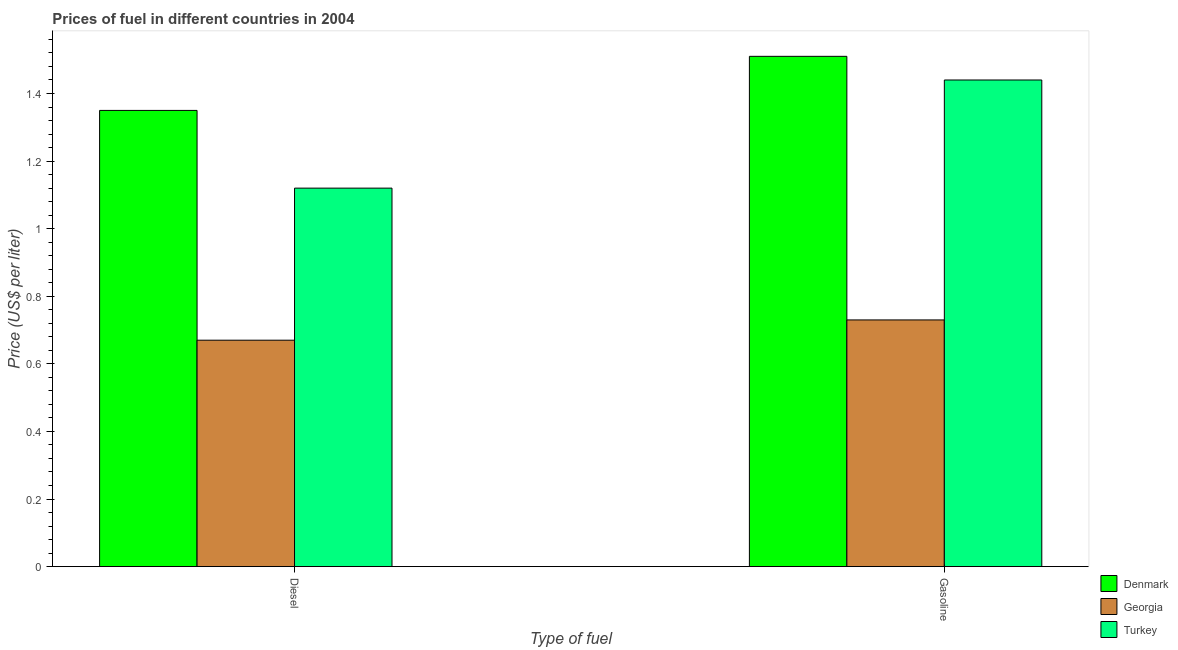How many groups of bars are there?
Give a very brief answer. 2. How many bars are there on the 2nd tick from the left?
Provide a short and direct response. 3. What is the label of the 2nd group of bars from the left?
Your answer should be very brief. Gasoline. What is the diesel price in Denmark?
Ensure brevity in your answer.  1.35. Across all countries, what is the maximum diesel price?
Give a very brief answer. 1.35. Across all countries, what is the minimum gasoline price?
Make the answer very short. 0.73. In which country was the gasoline price maximum?
Make the answer very short. Denmark. In which country was the diesel price minimum?
Your answer should be very brief. Georgia. What is the total gasoline price in the graph?
Your answer should be very brief. 3.68. What is the difference between the diesel price in Georgia and that in Turkey?
Give a very brief answer. -0.45. What is the difference between the gasoline price in Denmark and the diesel price in Georgia?
Keep it short and to the point. 0.84. What is the average gasoline price per country?
Provide a short and direct response. 1.23. What is the difference between the diesel price and gasoline price in Turkey?
Your answer should be compact. -0.32. What is the ratio of the gasoline price in Turkey to that in Denmark?
Your answer should be compact. 0.95. What does the 2nd bar from the right in Gasoline represents?
Make the answer very short. Georgia. Are all the bars in the graph horizontal?
Your response must be concise. No. Does the graph contain any zero values?
Provide a short and direct response. No. Does the graph contain grids?
Your answer should be very brief. No. What is the title of the graph?
Provide a succinct answer. Prices of fuel in different countries in 2004. What is the label or title of the X-axis?
Your answer should be compact. Type of fuel. What is the label or title of the Y-axis?
Keep it short and to the point. Price (US$ per liter). What is the Price (US$ per liter) in Denmark in Diesel?
Ensure brevity in your answer.  1.35. What is the Price (US$ per liter) of Georgia in Diesel?
Your response must be concise. 0.67. What is the Price (US$ per liter) in Turkey in Diesel?
Your response must be concise. 1.12. What is the Price (US$ per liter) in Denmark in Gasoline?
Give a very brief answer. 1.51. What is the Price (US$ per liter) of Georgia in Gasoline?
Offer a terse response. 0.73. What is the Price (US$ per liter) of Turkey in Gasoline?
Make the answer very short. 1.44. Across all Type of fuel, what is the maximum Price (US$ per liter) in Denmark?
Give a very brief answer. 1.51. Across all Type of fuel, what is the maximum Price (US$ per liter) in Georgia?
Offer a very short reply. 0.73. Across all Type of fuel, what is the maximum Price (US$ per liter) of Turkey?
Your answer should be very brief. 1.44. Across all Type of fuel, what is the minimum Price (US$ per liter) of Denmark?
Provide a succinct answer. 1.35. Across all Type of fuel, what is the minimum Price (US$ per liter) of Georgia?
Offer a terse response. 0.67. Across all Type of fuel, what is the minimum Price (US$ per liter) of Turkey?
Offer a terse response. 1.12. What is the total Price (US$ per liter) of Denmark in the graph?
Your answer should be compact. 2.86. What is the total Price (US$ per liter) in Turkey in the graph?
Offer a terse response. 2.56. What is the difference between the Price (US$ per liter) of Denmark in Diesel and that in Gasoline?
Ensure brevity in your answer.  -0.16. What is the difference between the Price (US$ per liter) of Georgia in Diesel and that in Gasoline?
Provide a succinct answer. -0.06. What is the difference between the Price (US$ per liter) of Turkey in Diesel and that in Gasoline?
Your answer should be very brief. -0.32. What is the difference between the Price (US$ per liter) in Denmark in Diesel and the Price (US$ per liter) in Georgia in Gasoline?
Provide a short and direct response. 0.62. What is the difference between the Price (US$ per liter) of Denmark in Diesel and the Price (US$ per liter) of Turkey in Gasoline?
Offer a terse response. -0.09. What is the difference between the Price (US$ per liter) in Georgia in Diesel and the Price (US$ per liter) in Turkey in Gasoline?
Keep it short and to the point. -0.77. What is the average Price (US$ per liter) in Denmark per Type of fuel?
Give a very brief answer. 1.43. What is the average Price (US$ per liter) of Turkey per Type of fuel?
Ensure brevity in your answer.  1.28. What is the difference between the Price (US$ per liter) in Denmark and Price (US$ per liter) in Georgia in Diesel?
Your answer should be very brief. 0.68. What is the difference between the Price (US$ per liter) of Denmark and Price (US$ per liter) of Turkey in Diesel?
Provide a short and direct response. 0.23. What is the difference between the Price (US$ per liter) of Georgia and Price (US$ per liter) of Turkey in Diesel?
Ensure brevity in your answer.  -0.45. What is the difference between the Price (US$ per liter) of Denmark and Price (US$ per liter) of Georgia in Gasoline?
Provide a short and direct response. 0.78. What is the difference between the Price (US$ per liter) of Denmark and Price (US$ per liter) of Turkey in Gasoline?
Offer a very short reply. 0.07. What is the difference between the Price (US$ per liter) of Georgia and Price (US$ per liter) of Turkey in Gasoline?
Your response must be concise. -0.71. What is the ratio of the Price (US$ per liter) of Denmark in Diesel to that in Gasoline?
Offer a terse response. 0.89. What is the ratio of the Price (US$ per liter) in Georgia in Diesel to that in Gasoline?
Provide a succinct answer. 0.92. What is the difference between the highest and the second highest Price (US$ per liter) of Denmark?
Provide a short and direct response. 0.16. What is the difference between the highest and the second highest Price (US$ per liter) in Georgia?
Make the answer very short. 0.06. What is the difference between the highest and the second highest Price (US$ per liter) of Turkey?
Provide a short and direct response. 0.32. What is the difference between the highest and the lowest Price (US$ per liter) of Denmark?
Make the answer very short. 0.16. What is the difference between the highest and the lowest Price (US$ per liter) in Turkey?
Provide a short and direct response. 0.32. 